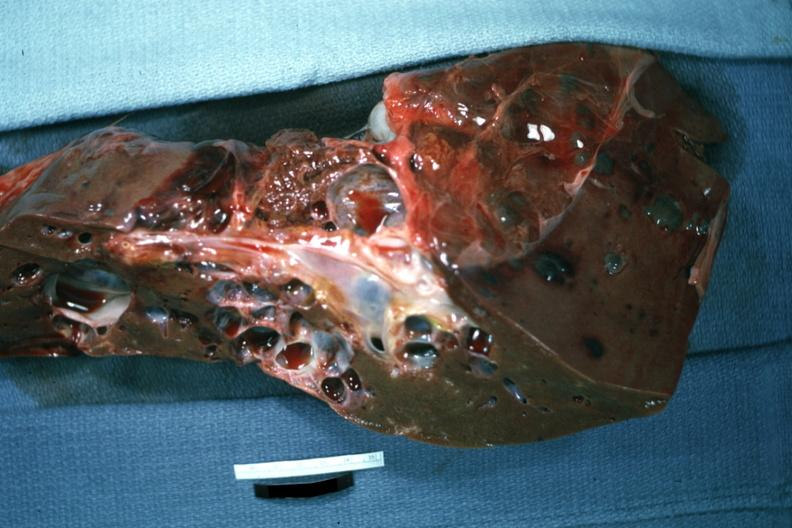does this image show cut surface with many cysts case of polycystic disease?
Answer the question using a single word or phrase. Yes 